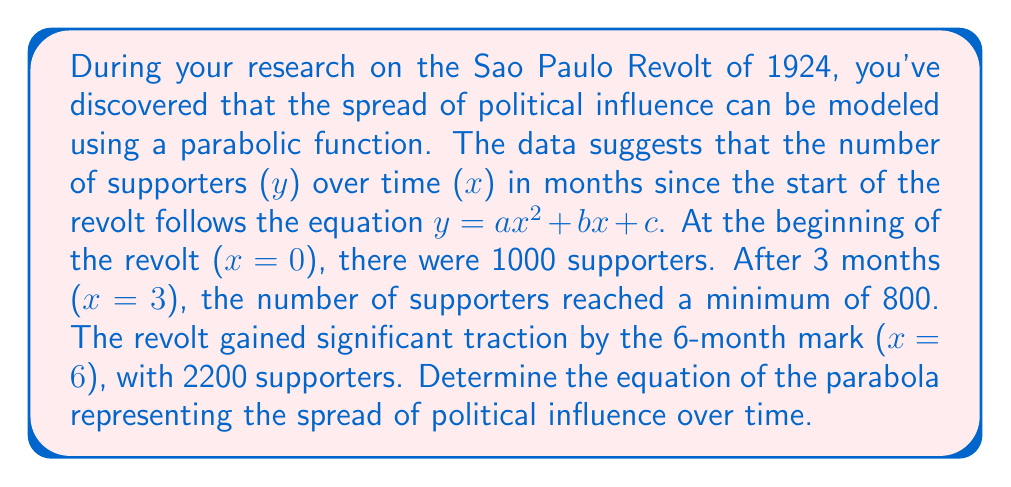What is the answer to this math problem? Let's approach this step-by-step:

1) We know the general form of a parabola is $y = ax^2 + bx + c$, where $a$, $b$, and $c$ are constants we need to determine.

2) We have three points that satisfy this equation:
   (0, 1000), (3, 800), and (6, 2200)

3) Let's start with the first point (0, 1000):
   $1000 = a(0)^2 + b(0) + c$
   $1000 = c$

4) Now we can substitute this into our general equation:
   $y = ax^2 + bx + 1000$

5) Using the other two points, we can create a system of equations:
   $800 = a(3)^2 + b(3) + 1000$
   $2200 = a(6)^2 + b(6) + 1000$

6) Simplify:
   $-200 = 9a + 3b$
   $1200 = 36a + 6b$

7) Multiply the first equation by 2 and the second by -1:
   $-400 = 18a + 6b$
   $-1200 = -36a - 6b$

8) Add these equations:
   $800 = 54a$
   $a = \frac{800}{54} = \frac{400}{27}$

9) Substitute this back into one of our simplified equations:
   $-200 = 9(\frac{400}{27}) + 3b$
   $-200 = \frac{3600}{27} + 3b$
   $-200 = \frac{400}{3} + 3b$
   $-600 = 400 + 9b$
   $-1000 = 9b$
   $b = -\frac{1000}{9}$

10) Now we have all our constants:
    $a = \frac{400}{27}$, $b = -\frac{1000}{9}$, $c = 1000$

Therefore, the equation of the parabola is:
$$y = \frac{400}{27}x^2 - \frac{1000}{9}x + 1000$$
Answer: $y = \frac{400}{27}x^2 - \frac{1000}{9}x + 1000$ 